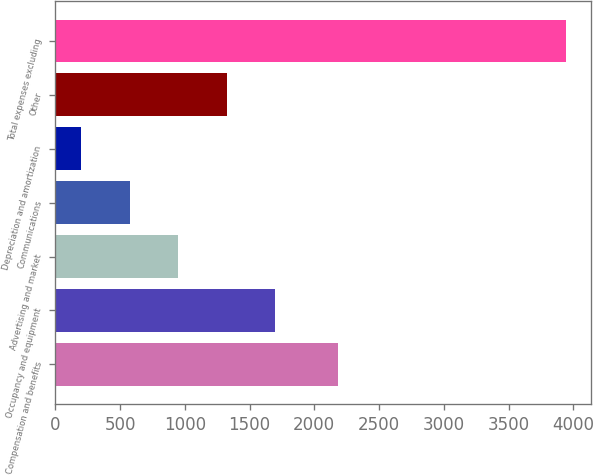Convert chart. <chart><loc_0><loc_0><loc_500><loc_500><bar_chart><fcel>Compensation and benefits<fcel>Occupancy and equipment<fcel>Advertising and market<fcel>Communications<fcel>Depreciation and amortization<fcel>Other<fcel>Total expenses excluding<nl><fcel>2184<fcel>1696.6<fcel>947.8<fcel>573.4<fcel>199<fcel>1322.2<fcel>3943<nl></chart> 